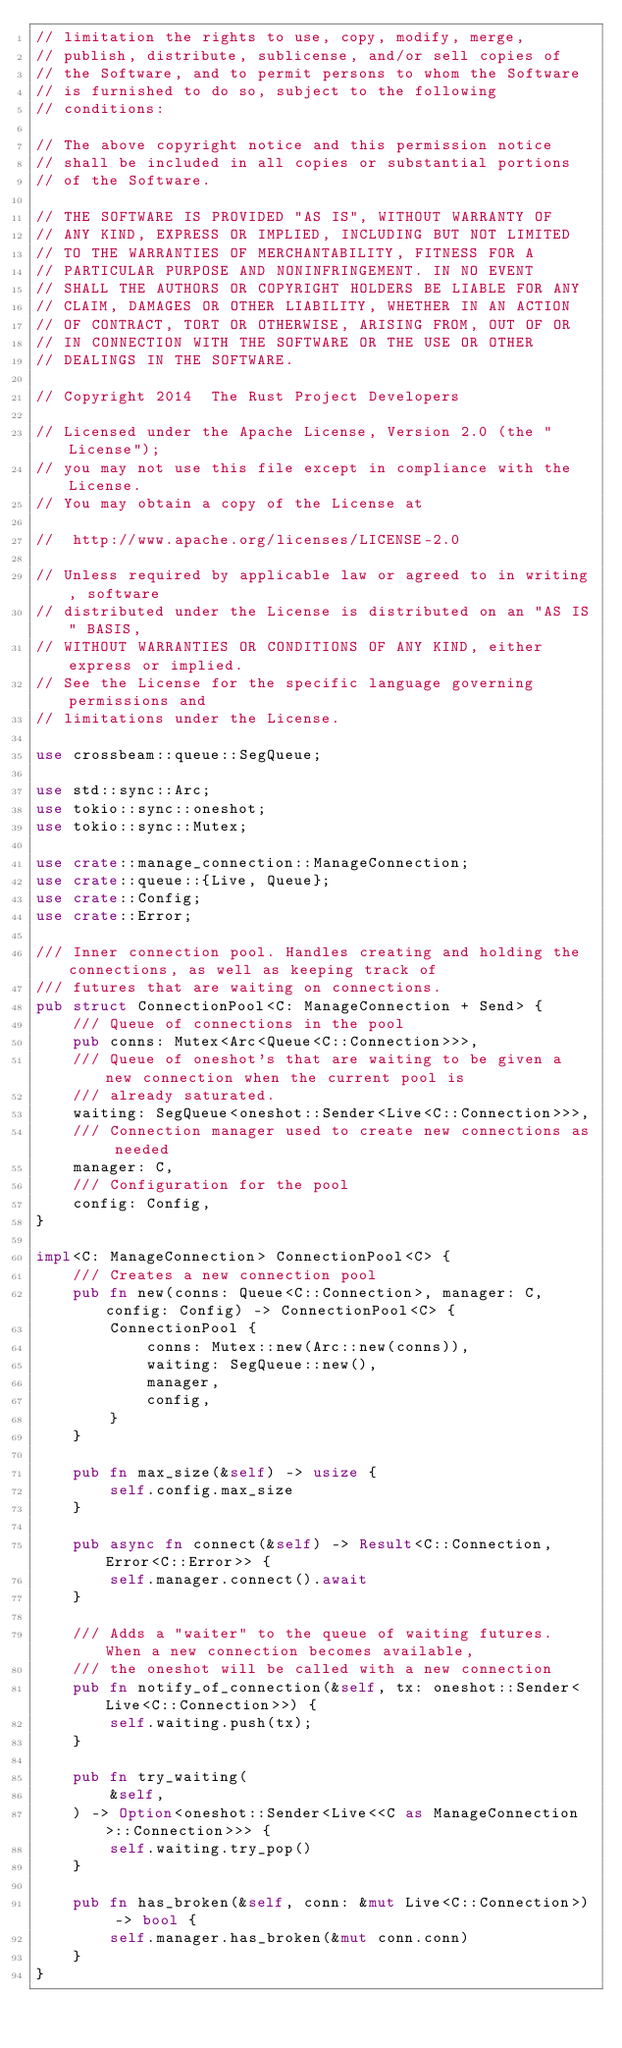Convert code to text. <code><loc_0><loc_0><loc_500><loc_500><_Rust_>// limitation the rights to use, copy, modify, merge,
// publish, distribute, sublicense, and/or sell copies of
// the Software, and to permit persons to whom the Software
// is furnished to do so, subject to the following
// conditions:

// The above copyright notice and this permission notice
// shall be included in all copies or substantial portions
// of the Software.

// THE SOFTWARE IS PROVIDED "AS IS", WITHOUT WARRANTY OF
// ANY KIND, EXPRESS OR IMPLIED, INCLUDING BUT NOT LIMITED
// TO THE WARRANTIES OF MERCHANTABILITY, FITNESS FOR A
// PARTICULAR PURPOSE AND NONINFRINGEMENT. IN NO EVENT
// SHALL THE AUTHORS OR COPYRIGHT HOLDERS BE LIABLE FOR ANY
// CLAIM, DAMAGES OR OTHER LIABILITY, WHETHER IN AN ACTION
// OF CONTRACT, TORT OR OTHERWISE, ARISING FROM, OUT OF OR
// IN CONNECTION WITH THE SOFTWARE OR THE USE OR OTHER
// DEALINGS IN THE SOFTWARE.

// Copyright 2014  The Rust Project Developers

// Licensed under the Apache License, Version 2.0 (the "License");
// you may not use this file except in compliance with the License.
// You may obtain a copy of the License at

// 	http://www.apache.org/licenses/LICENSE-2.0

// Unless required by applicable law or agreed to in writing, software
// distributed under the License is distributed on an "AS IS" BASIS,
// WITHOUT WARRANTIES OR CONDITIONS OF ANY KIND, either express or implied.
// See the License for the specific language governing permissions and
// limitations under the License.

use crossbeam::queue::SegQueue;

use std::sync::Arc;
use tokio::sync::oneshot;
use tokio::sync::Mutex;

use crate::manage_connection::ManageConnection;
use crate::queue::{Live, Queue};
use crate::Config;
use crate::Error;

/// Inner connection pool. Handles creating and holding the connections, as well as keeping track of
/// futures that are waiting on connections.
pub struct ConnectionPool<C: ManageConnection + Send> {
    /// Queue of connections in the pool
    pub conns: Mutex<Arc<Queue<C::Connection>>>,
    /// Queue of oneshot's that are waiting to be given a new connection when the current pool is
    /// already saturated.
    waiting: SegQueue<oneshot::Sender<Live<C::Connection>>>,
    /// Connection manager used to create new connections as needed
    manager: C,
    /// Configuration for the pool
    config: Config,
}

impl<C: ManageConnection> ConnectionPool<C> {
    /// Creates a new connection pool
    pub fn new(conns: Queue<C::Connection>, manager: C, config: Config) -> ConnectionPool<C> {
        ConnectionPool {
            conns: Mutex::new(Arc::new(conns)),
            waiting: SegQueue::new(),
            manager,
            config,
        }
    }

    pub fn max_size(&self) -> usize {
        self.config.max_size
    }

    pub async fn connect(&self) -> Result<C::Connection, Error<C::Error>> {
        self.manager.connect().await
    }

    /// Adds a "waiter" to the queue of waiting futures. When a new connection becomes available,
    /// the oneshot will be called with a new connection
    pub fn notify_of_connection(&self, tx: oneshot::Sender<Live<C::Connection>>) {
        self.waiting.push(tx);
    }

    pub fn try_waiting(
        &self,
    ) -> Option<oneshot::Sender<Live<<C as ManageConnection>::Connection>>> {
        self.waiting.try_pop()
    }

    pub fn has_broken(&self, conn: &mut Live<C::Connection>) -> bool {
        self.manager.has_broken(&mut conn.conn)
    }
}
</code> 